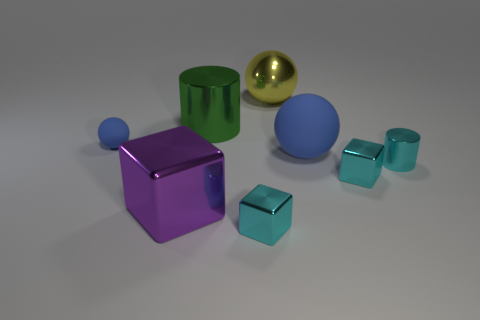Add 1 green cubes. How many objects exist? 9 Subtract all balls. How many objects are left? 5 Subtract 0 brown blocks. How many objects are left? 8 Subtract all cyan blocks. Subtract all small metallic blocks. How many objects are left? 4 Add 6 blue rubber balls. How many blue rubber balls are left? 8 Add 2 small rubber cubes. How many small rubber cubes exist? 2 